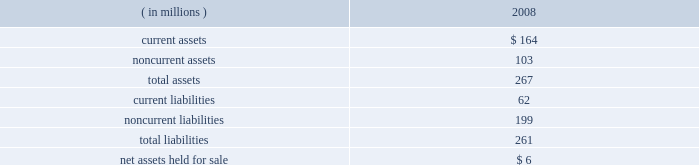Marathon oil corporation notes to consolidated financial statements 7 .
Dispositions outside-operated norwegian properties 2013 on october 31 , 2008 , we closed the sale of our norwegian outside-operated properties and undeveloped offshore acreage in the heimdal area of the norwegian north sea for net proceeds of $ 301 million , with a pretax gain of $ 254 million as of december 31 , 2008 .
Pilot travel centers 2013 on october 8 , 2008 , we completed the sale of our 50 percent ownership interest in ptc .
Sale proceeds were $ 625 million , with a pretax gain on the sale of $ 126 million .
Immediately preceding the sale , we received a $ 75 million partial redemption of our ownership interest from ptc that was accounted for as a return of investment .
Operated irish properties 2013 on december 17 , 2008 , we agreed to sell our operated properties located in ireland for proceeds of $ 180 million , before post-closing adjustments and cash on hand at closing .
Closing is subject to completion of the necessary administrative processes .
As of december 31 , 2008 , operating assets and liabilities were classified as held for sale , as disclosed by major class in the table : ( in millions ) 2008 .
Discontinued operations on june 2 , 2006 , we sold our russian oil exploration and production businesses in the khanty-mansiysk region of western siberia .
Under the terms of the agreement , we received $ 787 million for these businesses , plus preliminary working capital and other closing adjustments of $ 56 million , for a total transaction value of $ 843 million .
Proceeds net of transaction costs and cash held by the russian businesses at the transaction date totaled $ 832 million .
A gain on the sale of $ 243 million ( $ 342 million before income taxes ) was reported in discontinued operations for 2006 .
Income taxes on this gain were reduced by the utilization of a capital loss carryforward .
Exploration and production segment goodwill of $ 21 million was allocated to the russian assets and reduced the reported gain .
Adjustments to the sales price were completed in 2007 and an additional gain on the sale of $ 8 million ( $ 13 million before income taxes ) was recognized .
The activities of the russian businesses have been reported as discontinued operations in the consolidated statements of income and the consolidated statements of cash flows for 2006 .
Revenues applicable to discontinued operations were $ 173 million and pretax income from discontinued operations was $ 45 million for 2006. .
What is working capital for 2008? 
Rationale: for this question you need to know the formula for working capital which is ( working capital = current assets - current liabilities )
Computations: (164 - 62)
Answer: 102.0. Marathon oil corporation notes to consolidated financial statements 7 .
Dispositions outside-operated norwegian properties 2013 on october 31 , 2008 , we closed the sale of our norwegian outside-operated properties and undeveloped offshore acreage in the heimdal area of the norwegian north sea for net proceeds of $ 301 million , with a pretax gain of $ 254 million as of december 31 , 2008 .
Pilot travel centers 2013 on october 8 , 2008 , we completed the sale of our 50 percent ownership interest in ptc .
Sale proceeds were $ 625 million , with a pretax gain on the sale of $ 126 million .
Immediately preceding the sale , we received a $ 75 million partial redemption of our ownership interest from ptc that was accounted for as a return of investment .
Operated irish properties 2013 on december 17 , 2008 , we agreed to sell our operated properties located in ireland for proceeds of $ 180 million , before post-closing adjustments and cash on hand at closing .
Closing is subject to completion of the necessary administrative processes .
As of december 31 , 2008 , operating assets and liabilities were classified as held for sale , as disclosed by major class in the table : ( in millions ) 2008 .
Discontinued operations on june 2 , 2006 , we sold our russian oil exploration and production businesses in the khanty-mansiysk region of western siberia .
Under the terms of the agreement , we received $ 787 million for these businesses , plus preliminary working capital and other closing adjustments of $ 56 million , for a total transaction value of $ 843 million .
Proceeds net of transaction costs and cash held by the russian businesses at the transaction date totaled $ 832 million .
A gain on the sale of $ 243 million ( $ 342 million before income taxes ) was reported in discontinued operations for 2006 .
Income taxes on this gain were reduced by the utilization of a capital loss carryforward .
Exploration and production segment goodwill of $ 21 million was allocated to the russian assets and reduced the reported gain .
Adjustments to the sales price were completed in 2007 and an additional gain on the sale of $ 8 million ( $ 13 million before income taxes ) was recognized .
The activities of the russian businesses have been reported as discontinued operations in the consolidated statements of income and the consolidated statements of cash flows for 2006 .
Revenues applicable to discontinued operations were $ 173 million and pretax income from discontinued operations was $ 45 million for 2006. .
As of december 31 , 2008 what was the average of current assets and \\nnoncurrent assets , in millions? 
Computations: ((164 + 103) / 2)
Answer: 133.5. Marathon oil corporation notes to consolidated financial statements 7 .
Dispositions outside-operated norwegian properties 2013 on october 31 , 2008 , we closed the sale of our norwegian outside-operated properties and undeveloped offshore acreage in the heimdal area of the norwegian north sea for net proceeds of $ 301 million , with a pretax gain of $ 254 million as of december 31 , 2008 .
Pilot travel centers 2013 on october 8 , 2008 , we completed the sale of our 50 percent ownership interest in ptc .
Sale proceeds were $ 625 million , with a pretax gain on the sale of $ 126 million .
Immediately preceding the sale , we received a $ 75 million partial redemption of our ownership interest from ptc that was accounted for as a return of investment .
Operated irish properties 2013 on december 17 , 2008 , we agreed to sell our operated properties located in ireland for proceeds of $ 180 million , before post-closing adjustments and cash on hand at closing .
Closing is subject to completion of the necessary administrative processes .
As of december 31 , 2008 , operating assets and liabilities were classified as held for sale , as disclosed by major class in the table : ( in millions ) 2008 .
Discontinued operations on june 2 , 2006 , we sold our russian oil exploration and production businesses in the khanty-mansiysk region of western siberia .
Under the terms of the agreement , we received $ 787 million for these businesses , plus preliminary working capital and other closing adjustments of $ 56 million , for a total transaction value of $ 843 million .
Proceeds net of transaction costs and cash held by the russian businesses at the transaction date totaled $ 832 million .
A gain on the sale of $ 243 million ( $ 342 million before income taxes ) was reported in discontinued operations for 2006 .
Income taxes on this gain were reduced by the utilization of a capital loss carryforward .
Exploration and production segment goodwill of $ 21 million was allocated to the russian assets and reduced the reported gain .
Adjustments to the sales price were completed in 2007 and an additional gain on the sale of $ 8 million ( $ 13 million before income taxes ) was recognized .
The activities of the russian businesses have been reported as discontinued operations in the consolidated statements of income and the consolidated statements of cash flows for 2006 .
Revenues applicable to discontinued operations were $ 173 million and pretax income from discontinued operations was $ 45 million for 2006. .
What is the current ratio for 2008? 
Rationale: for this question you need to know the current ratio formula which is ff08current assets / current liabilities )
Computations: (164 / 62)
Answer: 2.64516. 